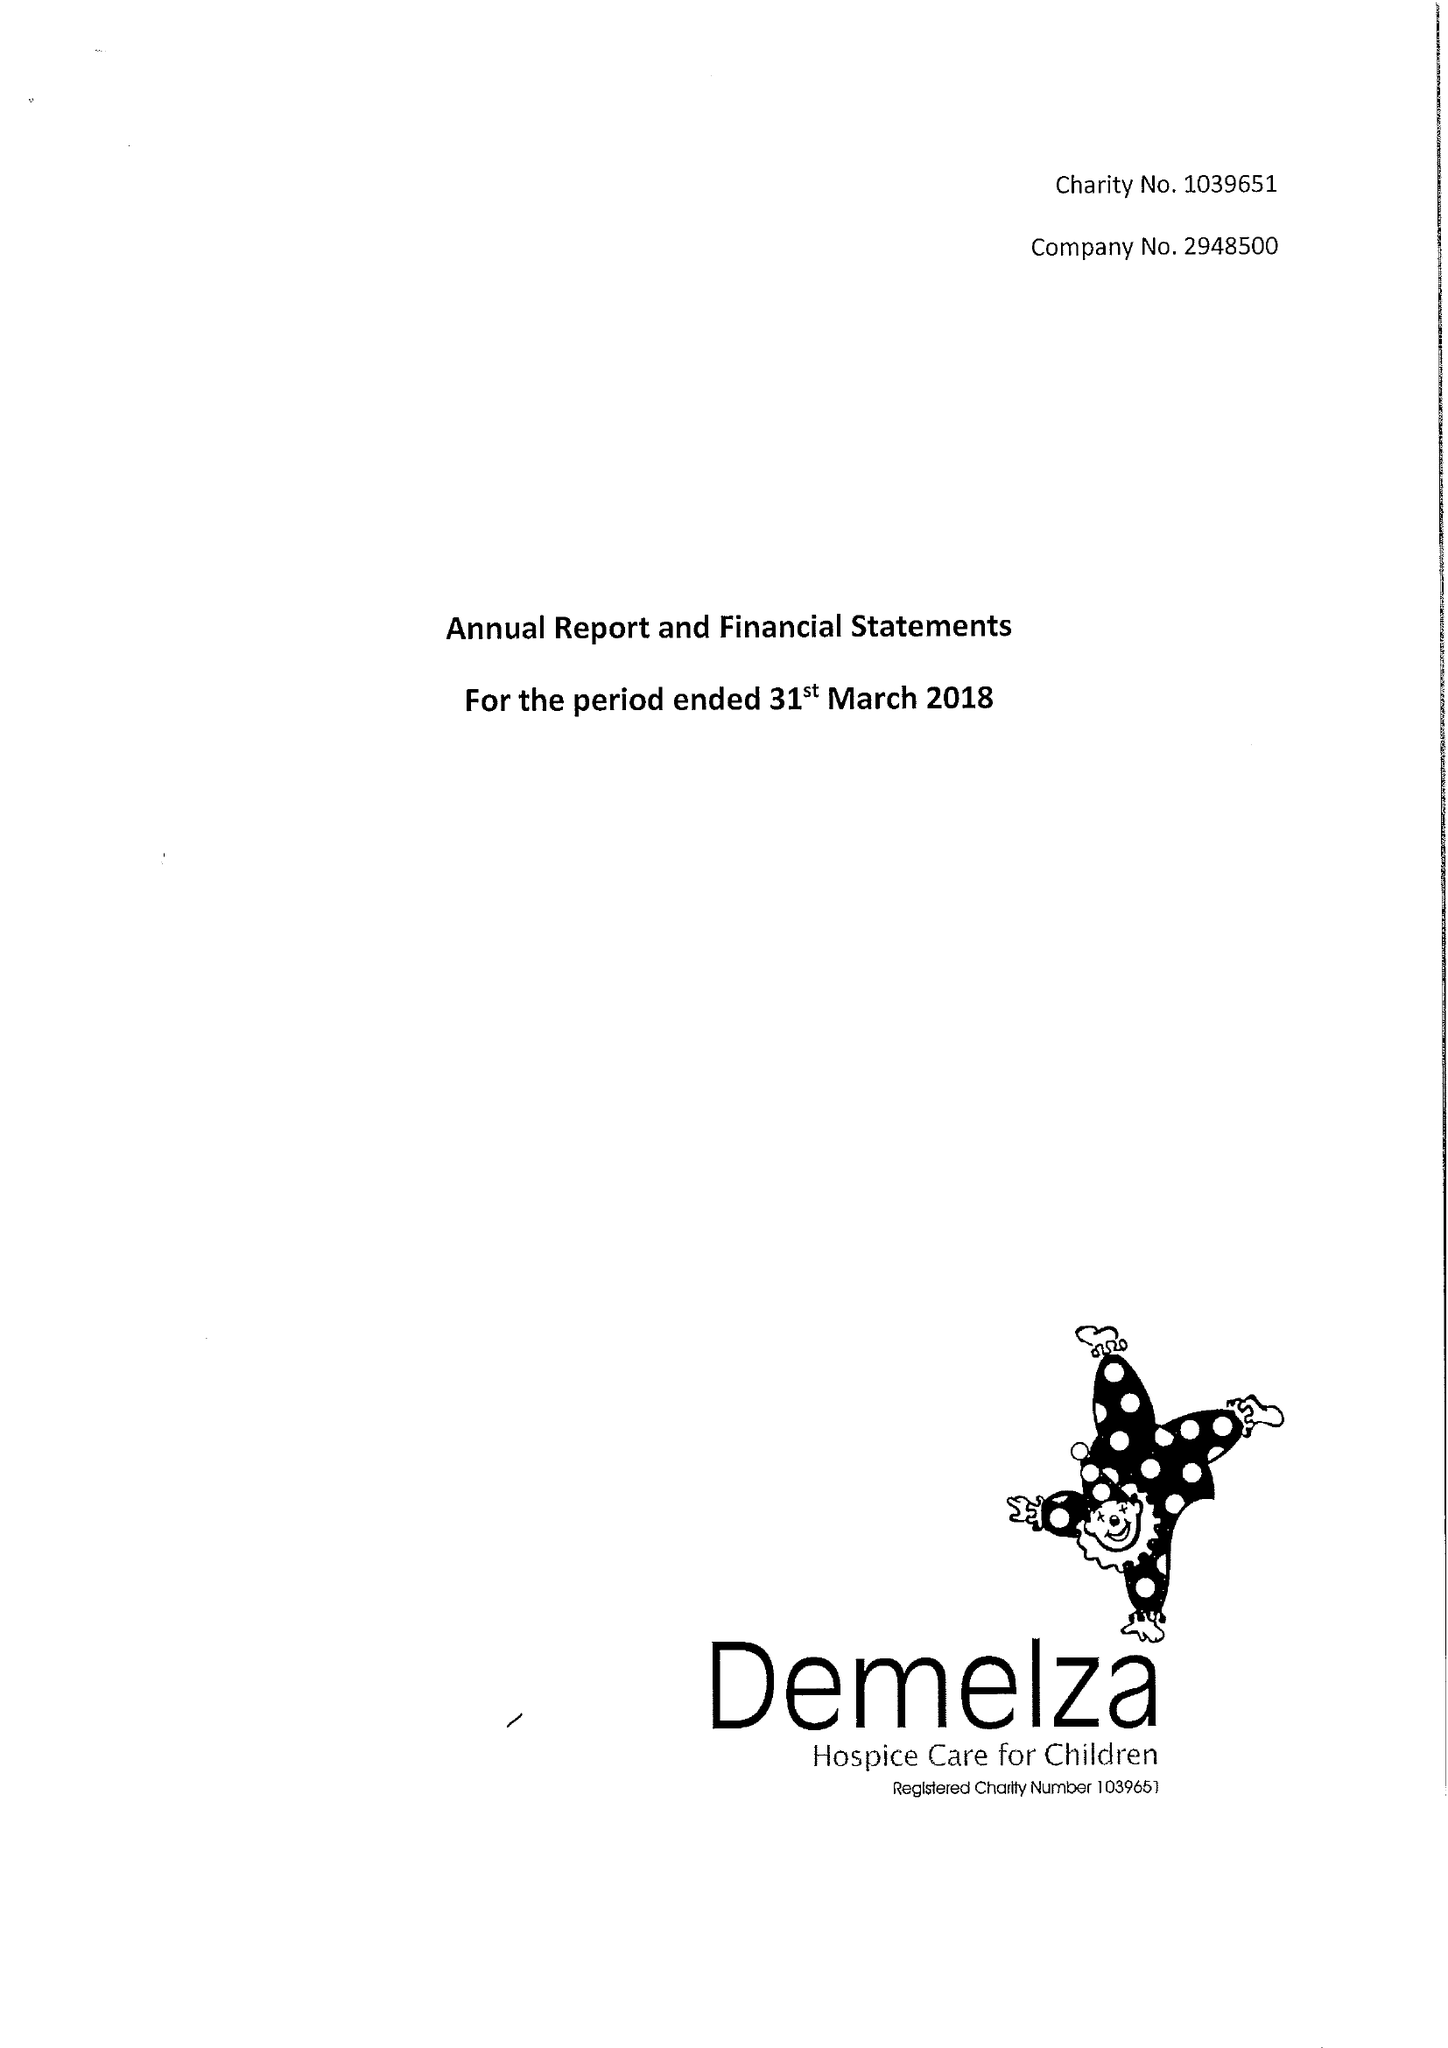What is the value for the report_date?
Answer the question using a single word or phrase. 2018-03-31 